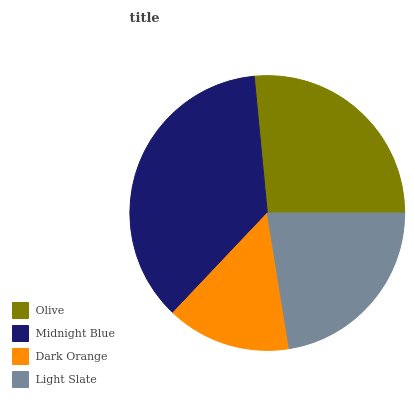Is Dark Orange the minimum?
Answer yes or no. Yes. Is Midnight Blue the maximum?
Answer yes or no. Yes. Is Midnight Blue the minimum?
Answer yes or no. No. Is Dark Orange the maximum?
Answer yes or no. No. Is Midnight Blue greater than Dark Orange?
Answer yes or no. Yes. Is Dark Orange less than Midnight Blue?
Answer yes or no. Yes. Is Dark Orange greater than Midnight Blue?
Answer yes or no. No. Is Midnight Blue less than Dark Orange?
Answer yes or no. No. Is Olive the high median?
Answer yes or no. Yes. Is Light Slate the low median?
Answer yes or no. Yes. Is Dark Orange the high median?
Answer yes or no. No. Is Olive the low median?
Answer yes or no. No. 